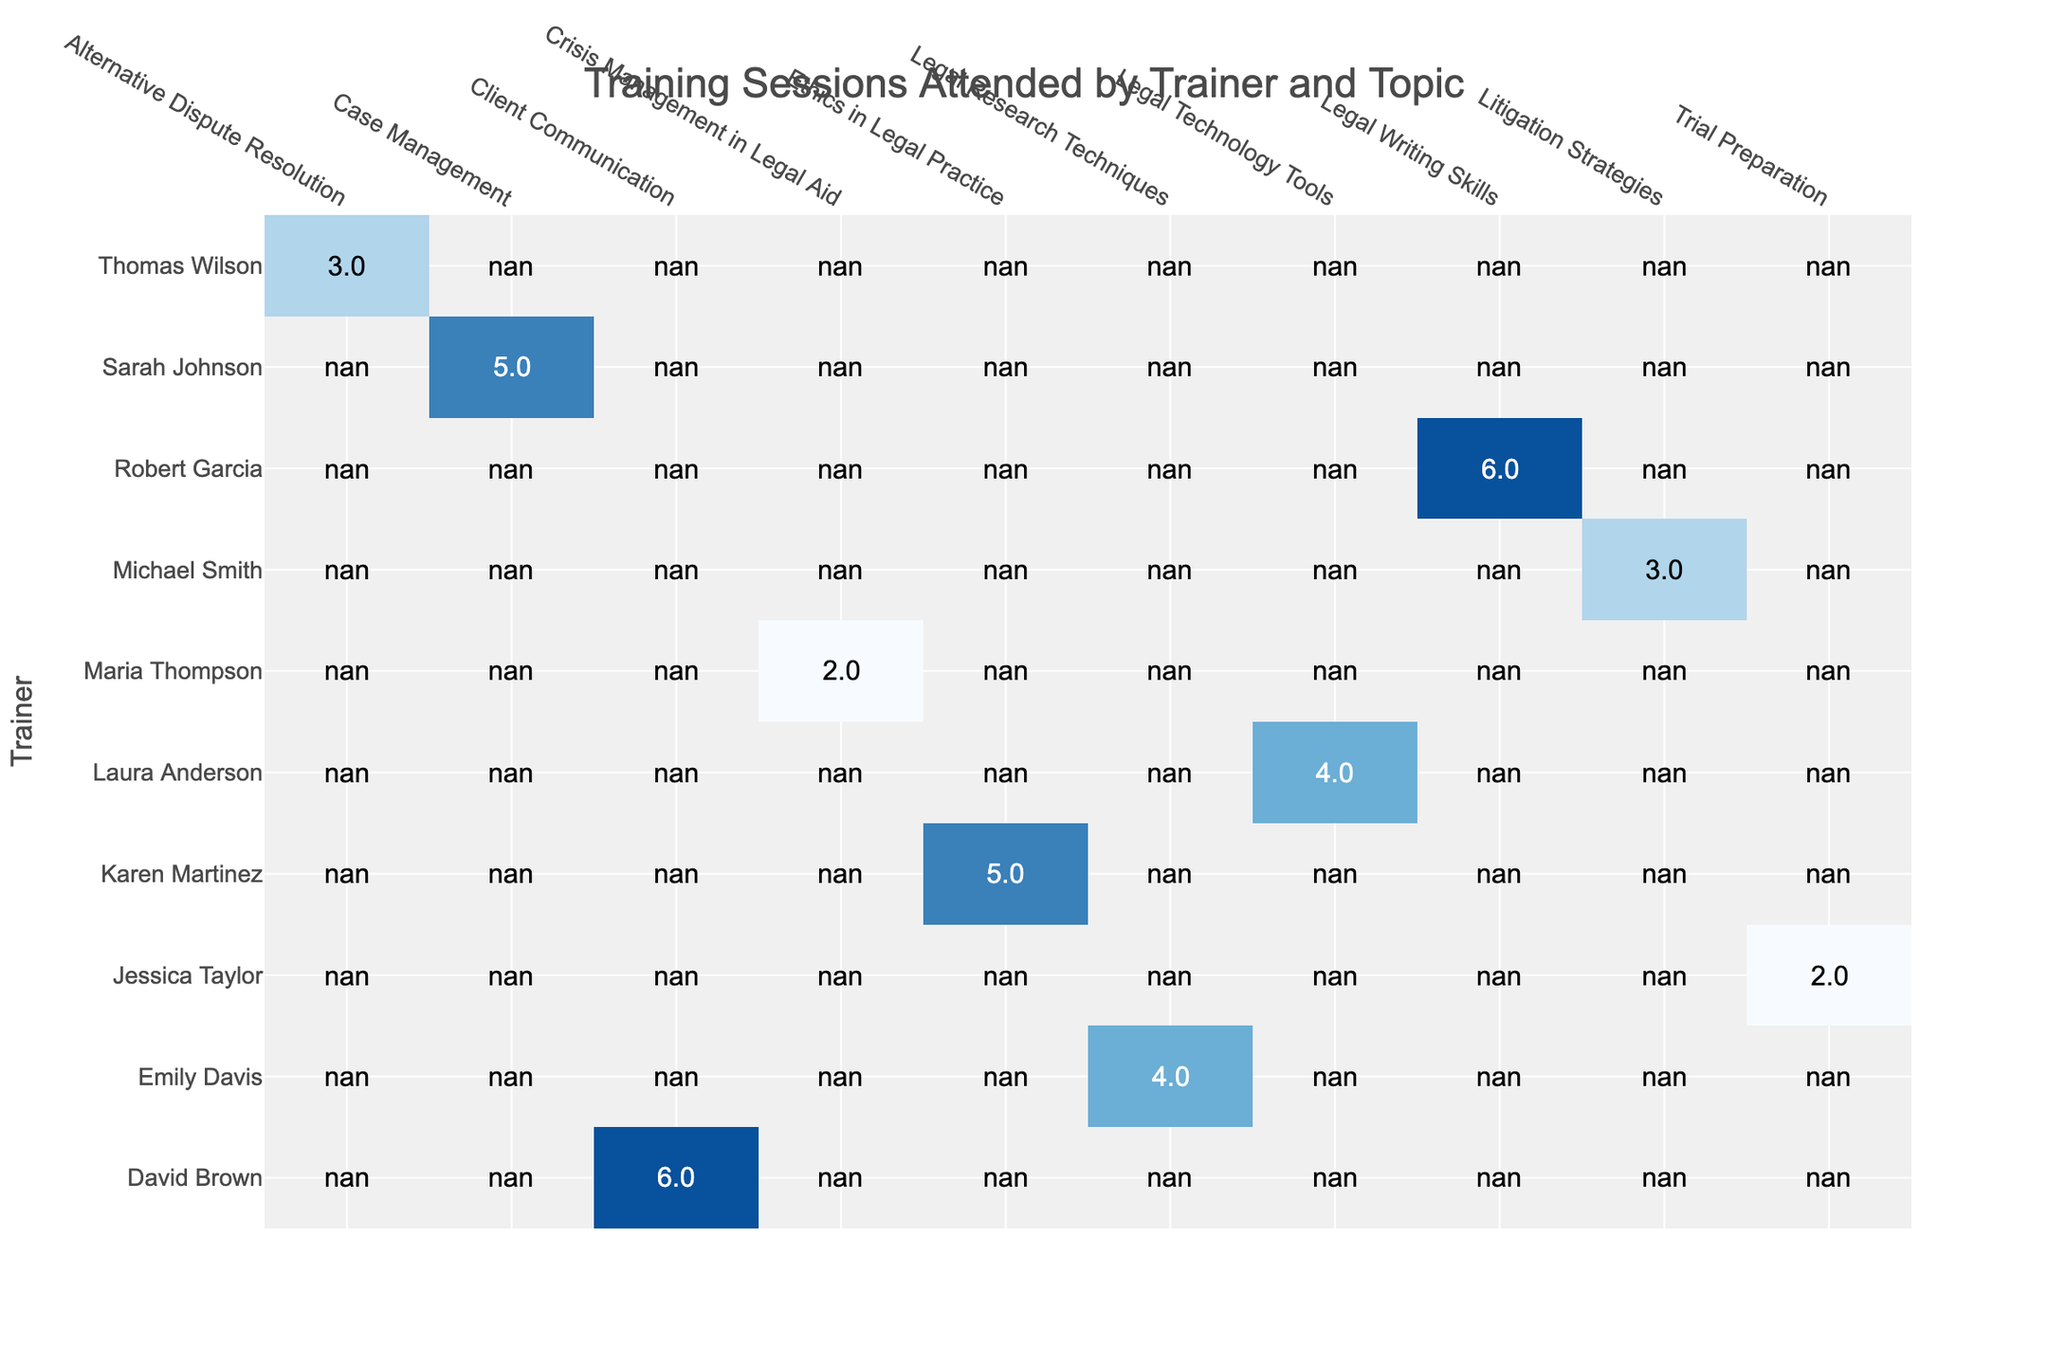What is the highest number of training sessions attended by a trainer for any topic? The trainer with the highest number of training sessions attended is David Brown, who conducted 6 sessions for Client Communication.
Answer: 6 Which topic had the least number of training sessions attended? The topic with the least number of training sessions attended is Trial Preparation and Crisis Management in Legal Aid, both at 2 sessions.
Answer: 2 How many training sessions did Robert Garcia conduct? Robert Garcia conducted 6 training sessions for Legal Writing Skills, as indicated in the table.
Answer: 6 Is there a topic that all trainers attended more than 3 training sessions on? No, there is no topic where all trainers attended more than 3 training sessions, as some trainers have attended fewer than 3 sessions for various topics.
Answer: No What is the total number of training sessions attended for Ethics in Legal Practice? Karen Martinez conducted 5 training sessions for the topic of Ethics in Legal Practice, which is the only data point for this topic in the table.
Answer: 5 What is the average number of training sessions attended per trainer? There are 10 data points for training sessions attended (5+3+4+6+2+3+5+6+4+2 = 40). To find the average, divide by the number of trainers (10), which results in 40/10 = 4.
Answer: 4 Which trainer has the expertise in Alternative Dispute Resolution, and how many sessions did they conduct? Thomas Wilson has expertise in Alternative Dispute Resolution and conducted 3 training sessions according to the table.
Answer: 3 What is the total number of training sessions attended by all trainers combined? By summing all training sessions from each trainer (5+3+4+6+2+3+5+6+4+2 = 40), the total number of training sessions attended by all trainers combined is 40.
Answer: 40 Which trainer conducted fewer than 4 training sessions? Michael Smith, Jessica Taylor, and Maria Thompson all conducted fewer than 4 training sessions (3, 2, and 2, respectively).
Answer: Yes, 3 trainers 